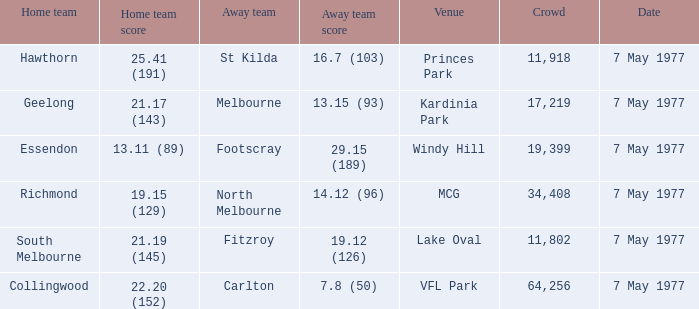Specify the place that has geelong as its home team. Kardinia Park. 